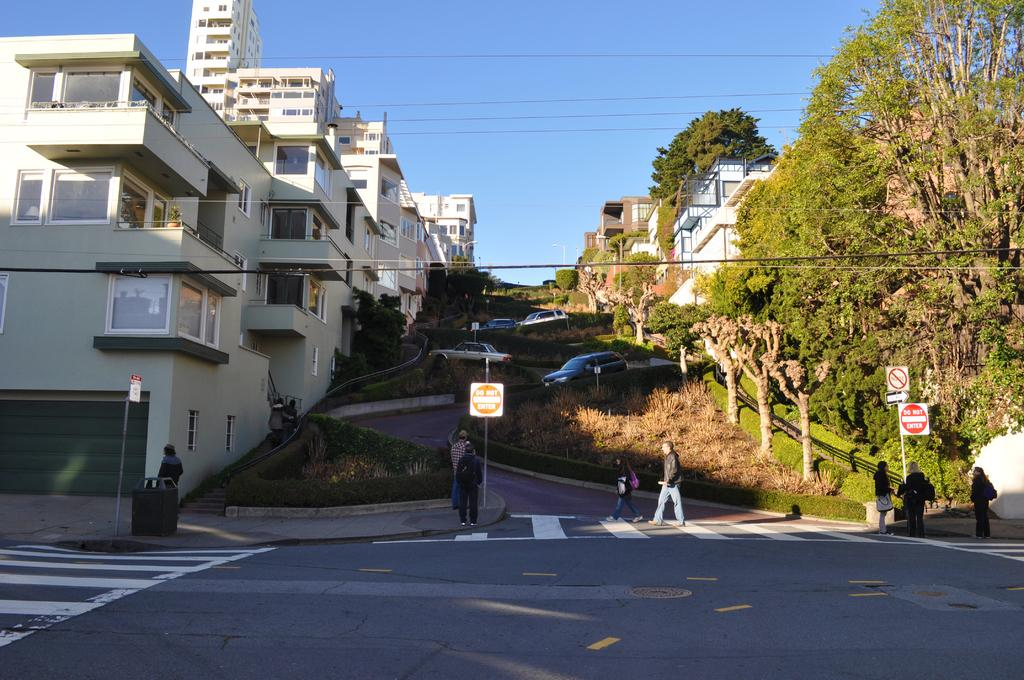What is the main subject of the image? The main subject of the image is vehicles on a curved street-road. What can be seen around the street-road? The street-road is surrounded by grass and there are trees present near the street-road. Are there any structures visible in the image? Yes, houses are visible in the vicinity of the street-road. What type of cart is being used for business purposes in the image? There is no cart or business activity present in the image; it features vehicles on a curved street-road surrounded by grass and trees. Can you see any mist in the image? There is no mist visible in the image; the sky and surroundings are clear. 